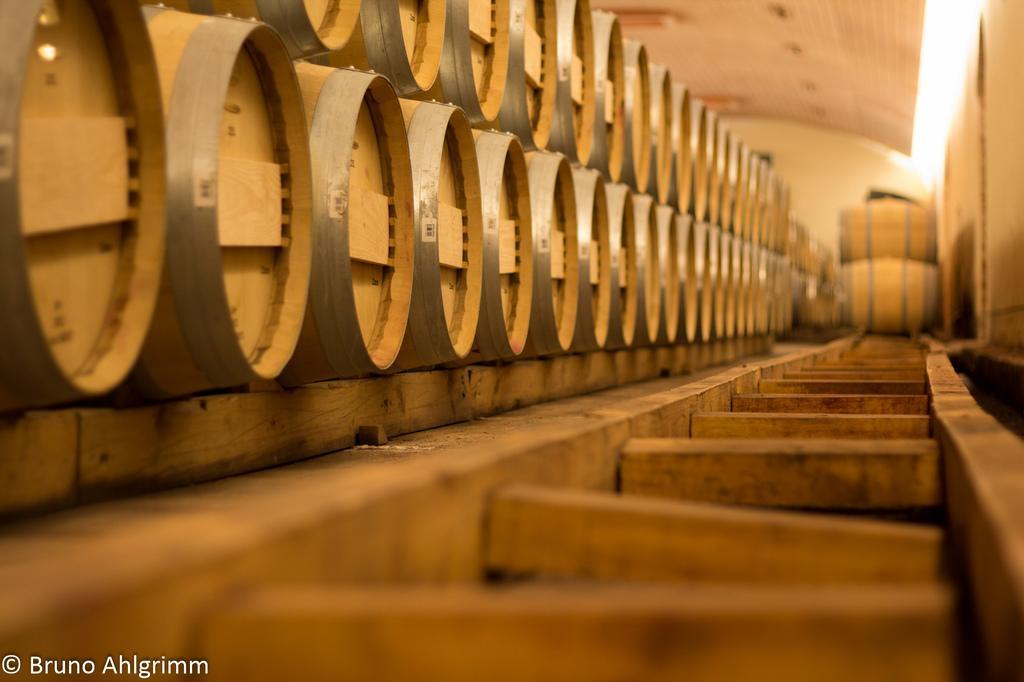Can you describe this image briefly? In this image, we can see many drums and at the bottom, there is wood and we can see some text. At the top, there is a roof. 